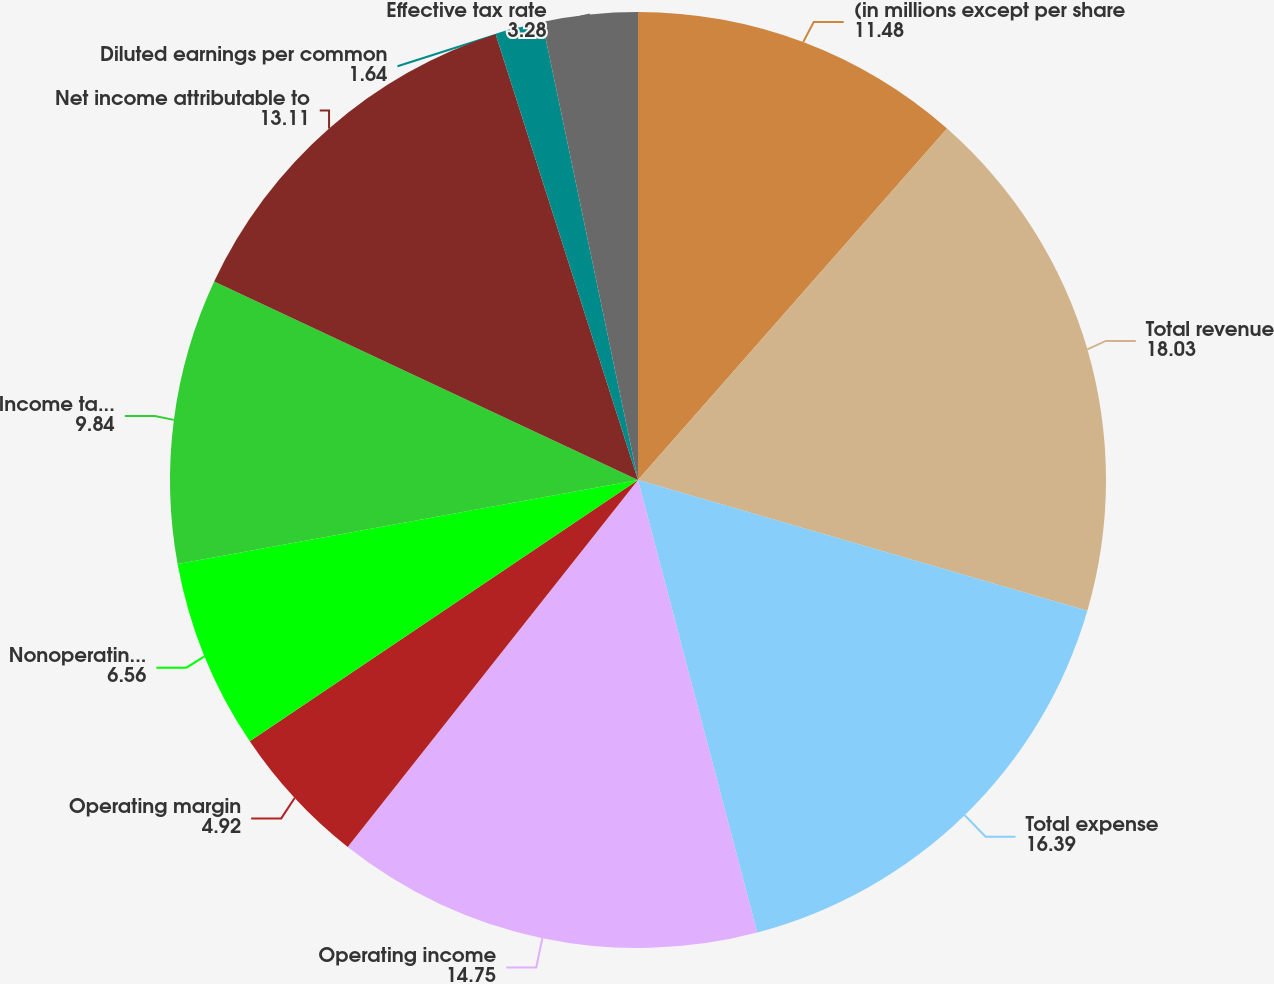Convert chart to OTSL. <chart><loc_0><loc_0><loc_500><loc_500><pie_chart><fcel>(in millions except per share<fcel>Total revenue<fcel>Total expense<fcel>Operating income<fcel>Operating margin<fcel>Nonoperating income (expense)<fcel>Income tax expense<fcel>Net income attributable to<fcel>Diluted earnings per common<fcel>Effective tax rate<nl><fcel>11.48%<fcel>18.03%<fcel>16.39%<fcel>14.75%<fcel>4.92%<fcel>6.56%<fcel>9.84%<fcel>13.11%<fcel>1.64%<fcel>3.28%<nl></chart> 